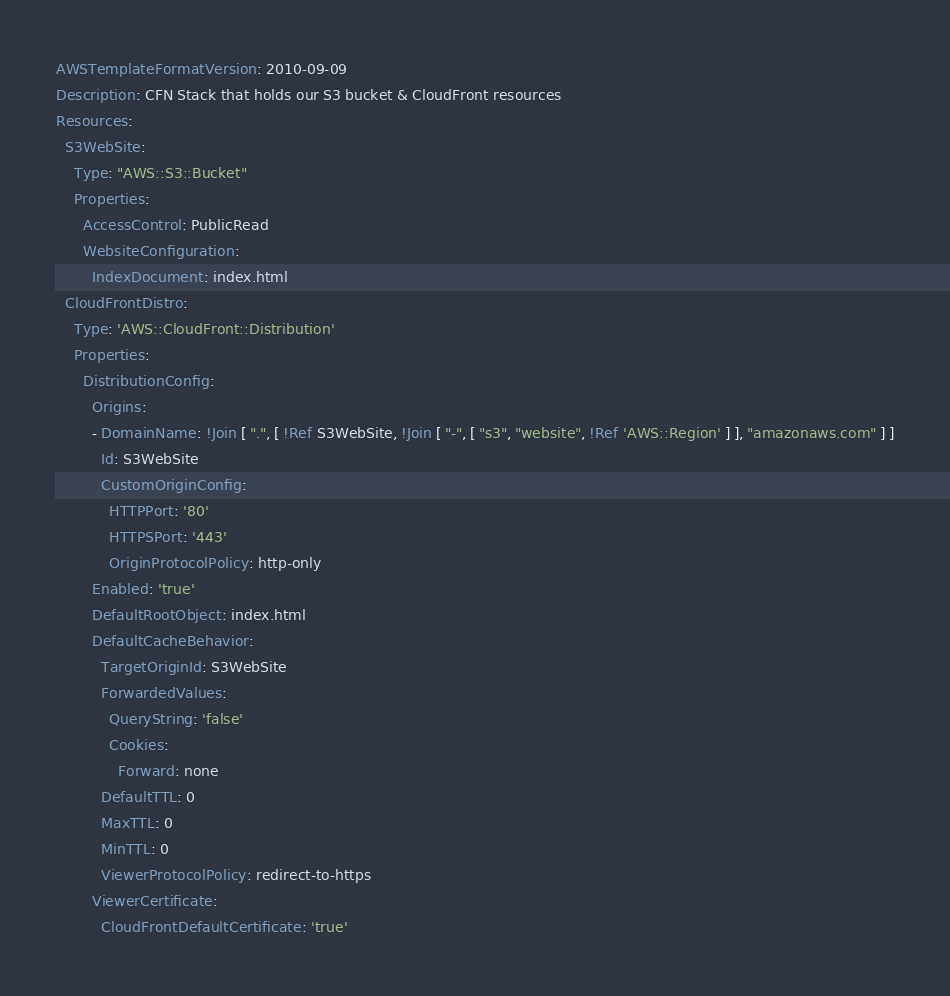<code> <loc_0><loc_0><loc_500><loc_500><_YAML_>AWSTemplateFormatVersion: 2010-09-09
Description: CFN Stack that holds our S3 bucket & CloudFront resources
Resources:
  S3WebSite:
    Type: "AWS::S3::Bucket"
    Properties:
      AccessControl: PublicRead
      WebsiteConfiguration:
        IndexDocument: index.html
  CloudFrontDistro:
    Type: 'AWS::CloudFront::Distribution'
    Properties:
      DistributionConfig:
        Origins:
        - DomainName: !Join [ ".", [ !Ref S3WebSite, !Join [ "-", [ "s3", "website", !Ref 'AWS::Region' ] ], "amazonaws.com" ] ]
          Id: S3WebSite
          CustomOriginConfig:
            HTTPPort: '80'
            HTTPSPort: '443'
            OriginProtocolPolicy: http-only
        Enabled: 'true'
        DefaultRootObject: index.html
        DefaultCacheBehavior:
          TargetOriginId: S3WebSite
          ForwardedValues:
            QueryString: 'false'
            Cookies:
              Forward: none
          DefaultTTL: 0
          MaxTTL: 0
          MinTTL: 0
          ViewerProtocolPolicy: redirect-to-https
        ViewerCertificate:
          CloudFrontDefaultCertificate: 'true'</code> 